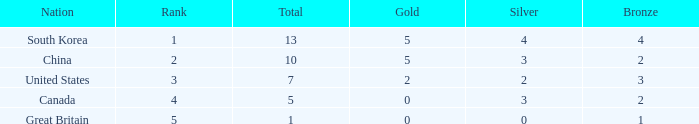What is Nation, when Rank is greater than 2, when Total is greater than 1, and when Bronze is less than 3? Canada. 